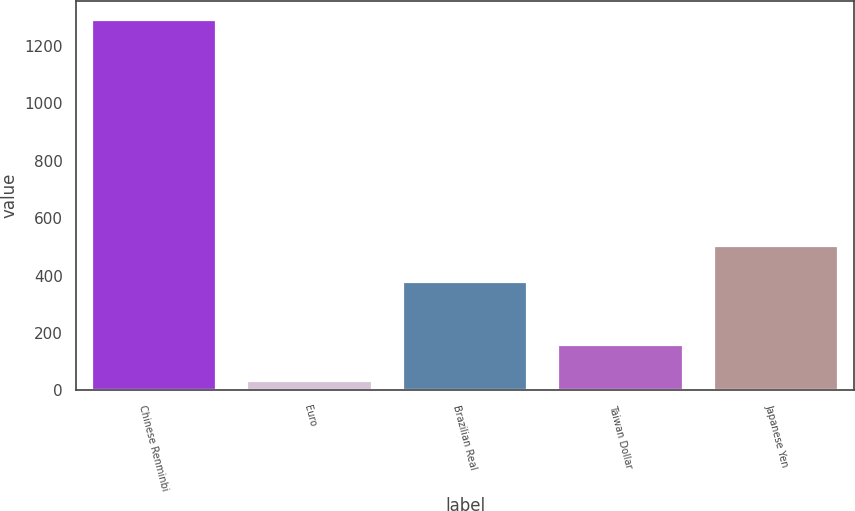Convert chart to OTSL. <chart><loc_0><loc_0><loc_500><loc_500><bar_chart><fcel>Chinese Renminbi<fcel>Euro<fcel>Brazilian Real<fcel>Taiwan Dollar<fcel>Japanese Yen<nl><fcel>1292<fcel>33<fcel>377<fcel>158.9<fcel>502.9<nl></chart> 